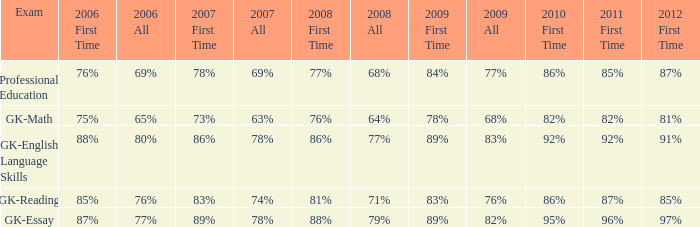What is the percentage for 2008 First time when in 2006 it was 85%? 81%. 